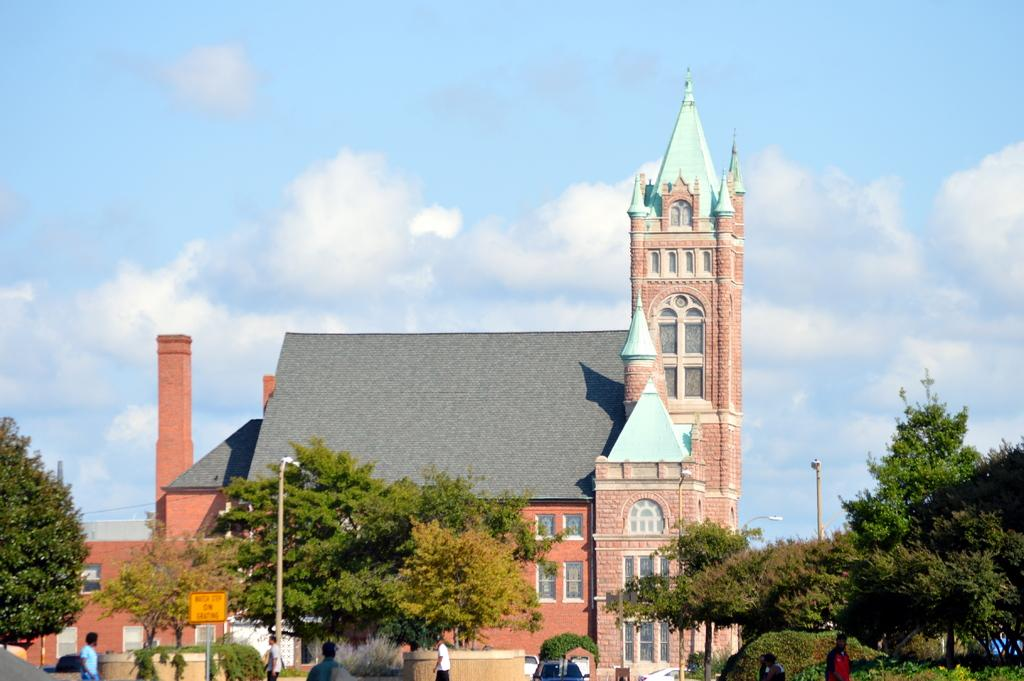What type of structure is visible in the image? There is a building in the image. What are the poles used for in the image? The poles are likely used for supporting lights or other objects in the image. Can you describe the lights in the image? Yes, there are lights visible in the image. What type of vegetation can be seen in the image? There are trees and plants in the image. Are there any vehicles in the image? Yes, there are vehicles in the image. What part of the building can be seen in the image? There are windows visible on the building in the image. Can you describe the people in the image? Yes, there are people present in the image. What is visible in the background of the image? The sky is visible in the background of the image, and clouds are present in the sky. What type of star can be seen shining brightly in the image? There is no star visible in the image; only the sky and clouds are present. What type of soap is being used by the people in the image? There is no soap visible in the image, and it is not possible to determine what the people might be using for cleaning. What type of chalk is being used by the people in the image? There is no chalk visible in the image, and it is not possible to determine what the people might be using for writing or drawing. 